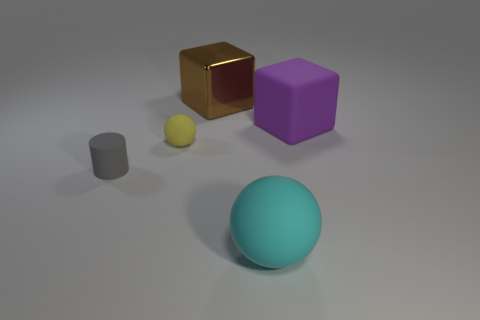What color is the rubber object that is the same size as the yellow sphere?
Your response must be concise. Gray. What is the color of the small ball?
Provide a succinct answer. Yellow. What is the material of the big brown block that is behind the tiny yellow ball?
Ensure brevity in your answer.  Metal. There is a purple matte thing that is the same shape as the large brown metal thing; what size is it?
Offer a very short reply. Large. Are there fewer tiny yellow spheres that are in front of the big matte ball than objects?
Make the answer very short. Yes. Are there any tiny purple rubber objects?
Offer a terse response. No. What is the color of the big rubber thing that is the same shape as the tiny yellow rubber object?
Your response must be concise. Cyan. Does the yellow rubber sphere have the same size as the purple matte object?
Keep it short and to the point. No. There is a big purple object that is the same material as the small ball; what is its shape?
Make the answer very short. Cube. How many other objects are there of the same shape as the small gray matte thing?
Provide a succinct answer. 0. 